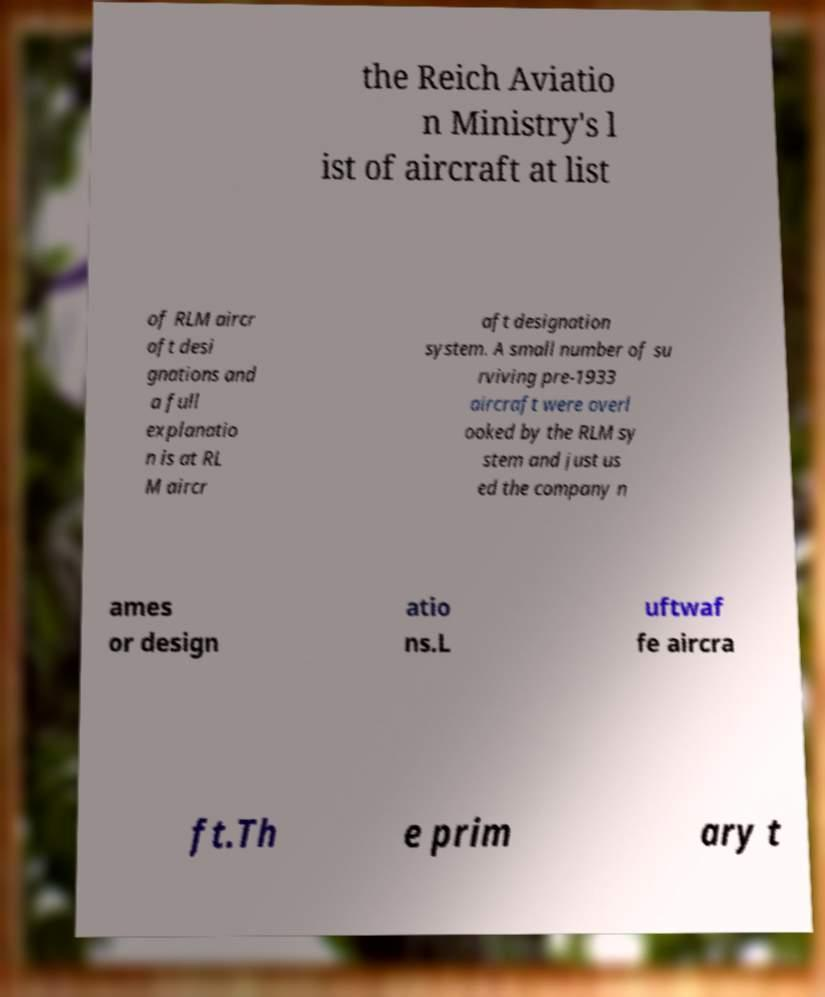Could you assist in decoding the text presented in this image and type it out clearly? the Reich Aviatio n Ministry's l ist of aircraft at list of RLM aircr aft desi gnations and a full explanatio n is at RL M aircr aft designation system. A small number of su rviving pre-1933 aircraft were overl ooked by the RLM sy stem and just us ed the company n ames or design atio ns.L uftwaf fe aircra ft.Th e prim ary t 